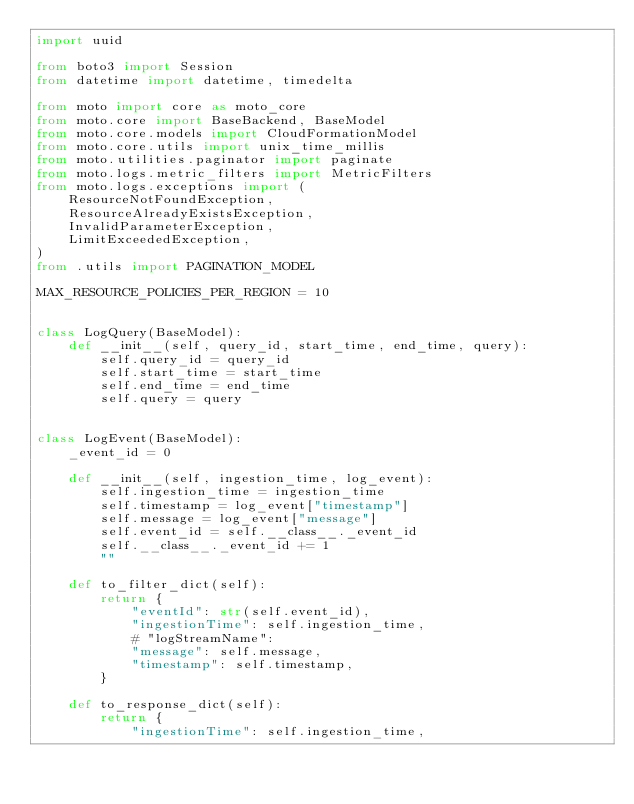<code> <loc_0><loc_0><loc_500><loc_500><_Python_>import uuid

from boto3 import Session
from datetime import datetime, timedelta

from moto import core as moto_core
from moto.core import BaseBackend, BaseModel
from moto.core.models import CloudFormationModel
from moto.core.utils import unix_time_millis
from moto.utilities.paginator import paginate
from moto.logs.metric_filters import MetricFilters
from moto.logs.exceptions import (
    ResourceNotFoundException,
    ResourceAlreadyExistsException,
    InvalidParameterException,
    LimitExceededException,
)
from .utils import PAGINATION_MODEL

MAX_RESOURCE_POLICIES_PER_REGION = 10


class LogQuery(BaseModel):
    def __init__(self, query_id, start_time, end_time, query):
        self.query_id = query_id
        self.start_time = start_time
        self.end_time = end_time
        self.query = query


class LogEvent(BaseModel):
    _event_id = 0

    def __init__(self, ingestion_time, log_event):
        self.ingestion_time = ingestion_time
        self.timestamp = log_event["timestamp"]
        self.message = log_event["message"]
        self.event_id = self.__class__._event_id
        self.__class__._event_id += 1
        ""

    def to_filter_dict(self):
        return {
            "eventId": str(self.event_id),
            "ingestionTime": self.ingestion_time,
            # "logStreamName":
            "message": self.message,
            "timestamp": self.timestamp,
        }

    def to_response_dict(self):
        return {
            "ingestionTime": self.ingestion_time,</code> 